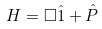Convert formula to latex. <formula><loc_0><loc_0><loc_500><loc_500>H = \Box { \hat { 1 } } + { \hat { P } }</formula> 